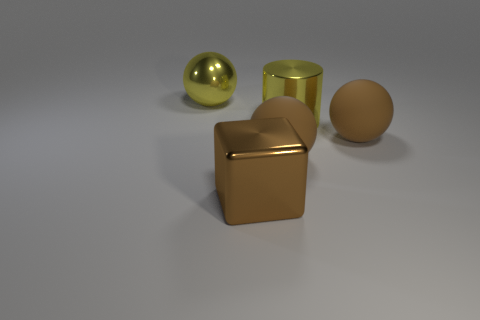Subtract all brown spheres. How many were subtracted if there are1brown spheres left? 1 Add 4 metallic balls. How many objects exist? 9 Subtract all balls. How many objects are left? 2 Subtract all big brown things. Subtract all brown metallic objects. How many objects are left? 1 Add 2 big brown rubber things. How many big brown rubber things are left? 4 Add 2 yellow metal spheres. How many yellow metal spheres exist? 3 Subtract 0 blue cylinders. How many objects are left? 5 